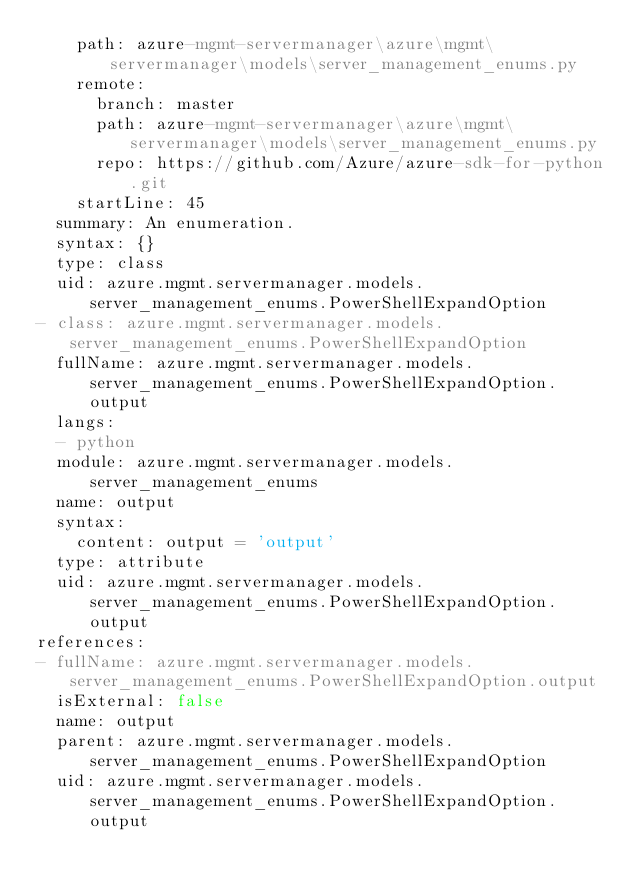Convert code to text. <code><loc_0><loc_0><loc_500><loc_500><_YAML_>    path: azure-mgmt-servermanager\azure\mgmt\servermanager\models\server_management_enums.py
    remote:
      branch: master
      path: azure-mgmt-servermanager\azure\mgmt\servermanager\models\server_management_enums.py
      repo: https://github.com/Azure/azure-sdk-for-python.git
    startLine: 45
  summary: An enumeration.
  syntax: {}
  type: class
  uid: azure.mgmt.servermanager.models.server_management_enums.PowerShellExpandOption
- class: azure.mgmt.servermanager.models.server_management_enums.PowerShellExpandOption
  fullName: azure.mgmt.servermanager.models.server_management_enums.PowerShellExpandOption.output
  langs:
  - python
  module: azure.mgmt.servermanager.models.server_management_enums
  name: output
  syntax:
    content: output = 'output'
  type: attribute
  uid: azure.mgmt.servermanager.models.server_management_enums.PowerShellExpandOption.output
references:
- fullName: azure.mgmt.servermanager.models.server_management_enums.PowerShellExpandOption.output
  isExternal: false
  name: output
  parent: azure.mgmt.servermanager.models.server_management_enums.PowerShellExpandOption
  uid: azure.mgmt.servermanager.models.server_management_enums.PowerShellExpandOption.output
</code> 